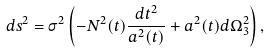<formula> <loc_0><loc_0><loc_500><loc_500>d s ^ { 2 } = \sigma ^ { 2 } \left ( - N ^ { 2 } ( t ) \frac { d t ^ { 2 } } { a ^ { 2 } ( t ) } + a ^ { 2 } ( t ) d \Omega ^ { 2 } _ { 3 } \right ) ,</formula> 